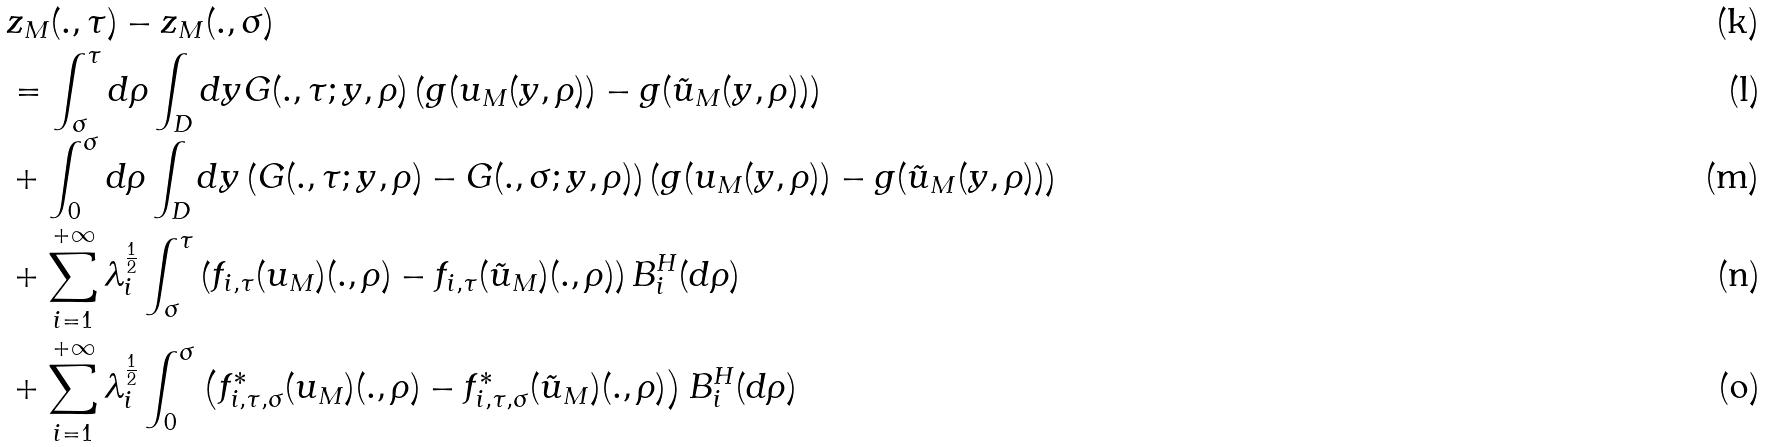<formula> <loc_0><loc_0><loc_500><loc_500>& z _ { M } ( . , \tau ) - z _ { M } ( . , \sigma ) \\ & = \int _ { \sigma } ^ { \tau } d \rho \int _ { D } d y G ( . , \tau ; y , \rho ) \left ( g ( u _ { M } ( y , \rho ) ) - g ( \tilde { u } _ { M } ( y , \rho ) ) \right ) \\ & + \int _ { 0 } ^ { \sigma } d \rho \int _ { D } d y \left ( G ( . , \tau ; y , \rho ) - G ( . , \sigma ; y , \rho ) \right ) \left ( g ( u _ { M } ( y , \rho ) ) - g ( \tilde { u } _ { M } ( y , \rho ) ) \right ) \\ & + \sum _ { i = 1 } ^ { + \infty } \lambda _ { i } ^ { \frac { 1 } { 2 } } \int _ { \sigma } ^ { \tau } \left ( f _ { i , \tau } ( u _ { M } ) ( . , \rho ) - f _ { i , \tau } ( \tilde { u } _ { M } ) ( . , \rho ) \right ) B _ { i } ^ { H } ( d \rho ) \\ & + \sum _ { i = 1 } ^ { + \infty } \lambda _ { i } ^ { \frac { 1 } { 2 } } \int _ { 0 } ^ { \sigma } \left ( f _ { i , \tau , \sigma } ^ { \ast } ( u _ { M } ) ( . , \rho ) - f _ { i , \tau , \sigma } ^ { \ast } ( \tilde { u } _ { M } ) ( . , \rho ) \right ) B _ { i } ^ { H } ( d \rho )</formula> 